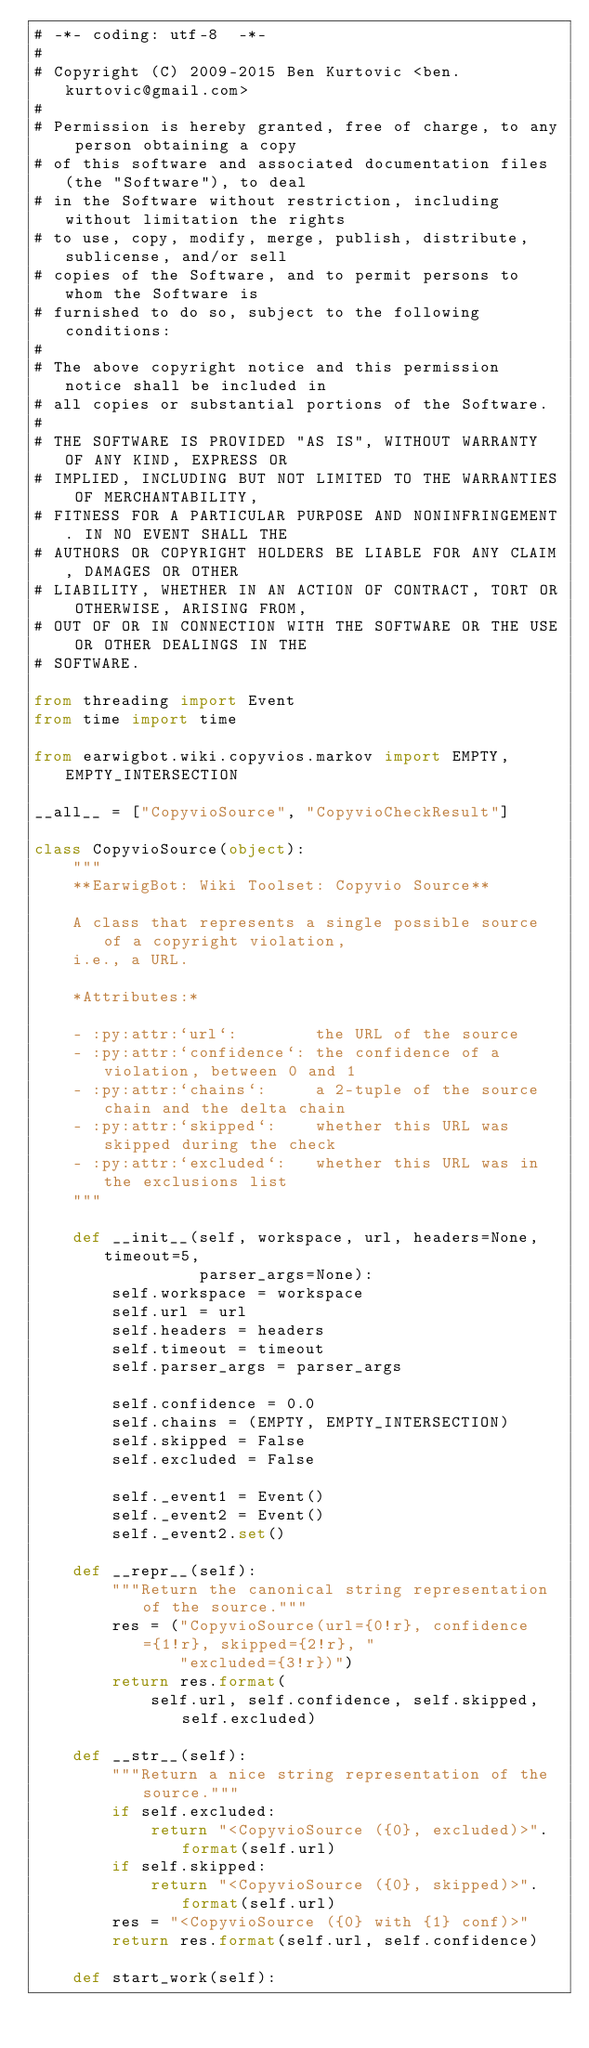<code> <loc_0><loc_0><loc_500><loc_500><_Python_># -*- coding: utf-8  -*-
#
# Copyright (C) 2009-2015 Ben Kurtovic <ben.kurtovic@gmail.com>
#
# Permission is hereby granted, free of charge, to any person obtaining a copy
# of this software and associated documentation files (the "Software"), to deal
# in the Software without restriction, including without limitation the rights
# to use, copy, modify, merge, publish, distribute, sublicense, and/or sell
# copies of the Software, and to permit persons to whom the Software is
# furnished to do so, subject to the following conditions:
#
# The above copyright notice and this permission notice shall be included in
# all copies or substantial portions of the Software.
#
# THE SOFTWARE IS PROVIDED "AS IS", WITHOUT WARRANTY OF ANY KIND, EXPRESS OR
# IMPLIED, INCLUDING BUT NOT LIMITED TO THE WARRANTIES OF MERCHANTABILITY,
# FITNESS FOR A PARTICULAR PURPOSE AND NONINFRINGEMENT. IN NO EVENT SHALL THE
# AUTHORS OR COPYRIGHT HOLDERS BE LIABLE FOR ANY CLAIM, DAMAGES OR OTHER
# LIABILITY, WHETHER IN AN ACTION OF CONTRACT, TORT OR OTHERWISE, ARISING FROM,
# OUT OF OR IN CONNECTION WITH THE SOFTWARE OR THE USE OR OTHER DEALINGS IN THE
# SOFTWARE.

from threading import Event
from time import time

from earwigbot.wiki.copyvios.markov import EMPTY, EMPTY_INTERSECTION

__all__ = ["CopyvioSource", "CopyvioCheckResult"]

class CopyvioSource(object):
    """
    **EarwigBot: Wiki Toolset: Copyvio Source**

    A class that represents a single possible source of a copyright violation,
    i.e., a URL.

    *Attributes:*

    - :py:attr:`url`:        the URL of the source
    - :py:attr:`confidence`: the confidence of a violation, between 0 and 1
    - :py:attr:`chains`:     a 2-tuple of the source chain and the delta chain
    - :py:attr:`skipped`:    whether this URL was skipped during the check
    - :py:attr:`excluded`:   whether this URL was in the exclusions list
    """

    def __init__(self, workspace, url, headers=None, timeout=5,
                 parser_args=None):
        self.workspace = workspace
        self.url = url
        self.headers = headers
        self.timeout = timeout
        self.parser_args = parser_args

        self.confidence = 0.0
        self.chains = (EMPTY, EMPTY_INTERSECTION)
        self.skipped = False
        self.excluded = False

        self._event1 = Event()
        self._event2 = Event()
        self._event2.set()

    def __repr__(self):
        """Return the canonical string representation of the source."""
        res = ("CopyvioSource(url={0!r}, confidence={1!r}, skipped={2!r}, "
               "excluded={3!r})")
        return res.format(
            self.url, self.confidence, self.skipped, self.excluded)

    def __str__(self):
        """Return a nice string representation of the source."""
        if self.excluded:
            return "<CopyvioSource ({0}, excluded)>".format(self.url)
        if self.skipped:
            return "<CopyvioSource ({0}, skipped)>".format(self.url)
        res = "<CopyvioSource ({0} with {1} conf)>"
        return res.format(self.url, self.confidence)

    def start_work(self):</code> 